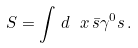Convert formula to latex. <formula><loc_0><loc_0><loc_500><loc_500>S = \int \, d \ x \, \bar { s } \gamma ^ { 0 } s \, .</formula> 